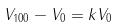<formula> <loc_0><loc_0><loc_500><loc_500>V _ { 1 0 0 } - V _ { 0 } = k V _ { 0 }</formula> 